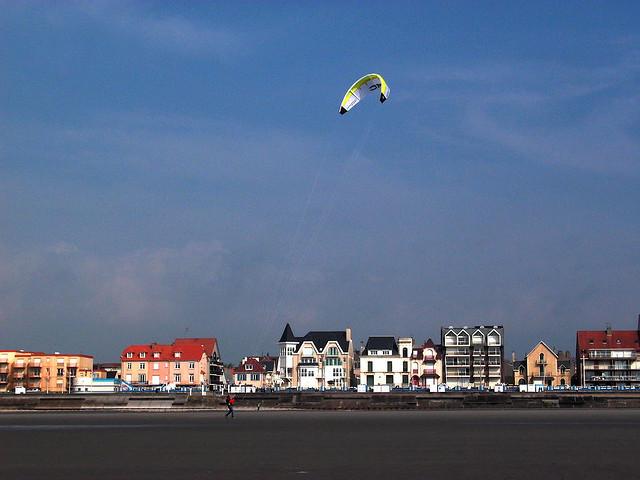How many houses are pictured?
Answer briefly. 9. How many clock faces are there?
Be succinct. 0. Is that a kite?
Answer briefly. Yes. What season could this be?
Concise answer only. Summer. 